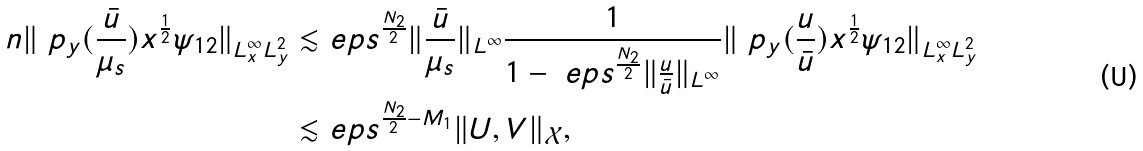<formula> <loc_0><loc_0><loc_500><loc_500>\ n \| \ p _ { y } ( \frac { \bar { u } } { \mu _ { s } } ) x ^ { \frac { 1 } { 2 } } \psi _ { 1 2 } \| _ { L ^ { \infty } _ { x } L ^ { 2 } _ { y } } \lesssim & \ e p s ^ { \frac { N _ { 2 } } { 2 } } \| \frac { \bar { u } } { \mu _ { s } } \| _ { L ^ { \infty } } \frac { 1 } { 1 - \ e p s ^ { \frac { N _ { 2 } } { 2 } } \| \frac { u } { \bar { u } } \| _ { L ^ { \infty } } } \| \ p _ { y } ( \frac { u } { \bar { u } } ) x ^ { \frac { 1 } { 2 } } \psi _ { 1 2 } \| _ { L ^ { \infty } _ { x } L ^ { 2 } _ { y } } \\ \lesssim & \ e p s ^ { \frac { N _ { 2 } } { 2 } - M _ { 1 } } \| U , V \| _ { \mathcal { X } } ,</formula> 